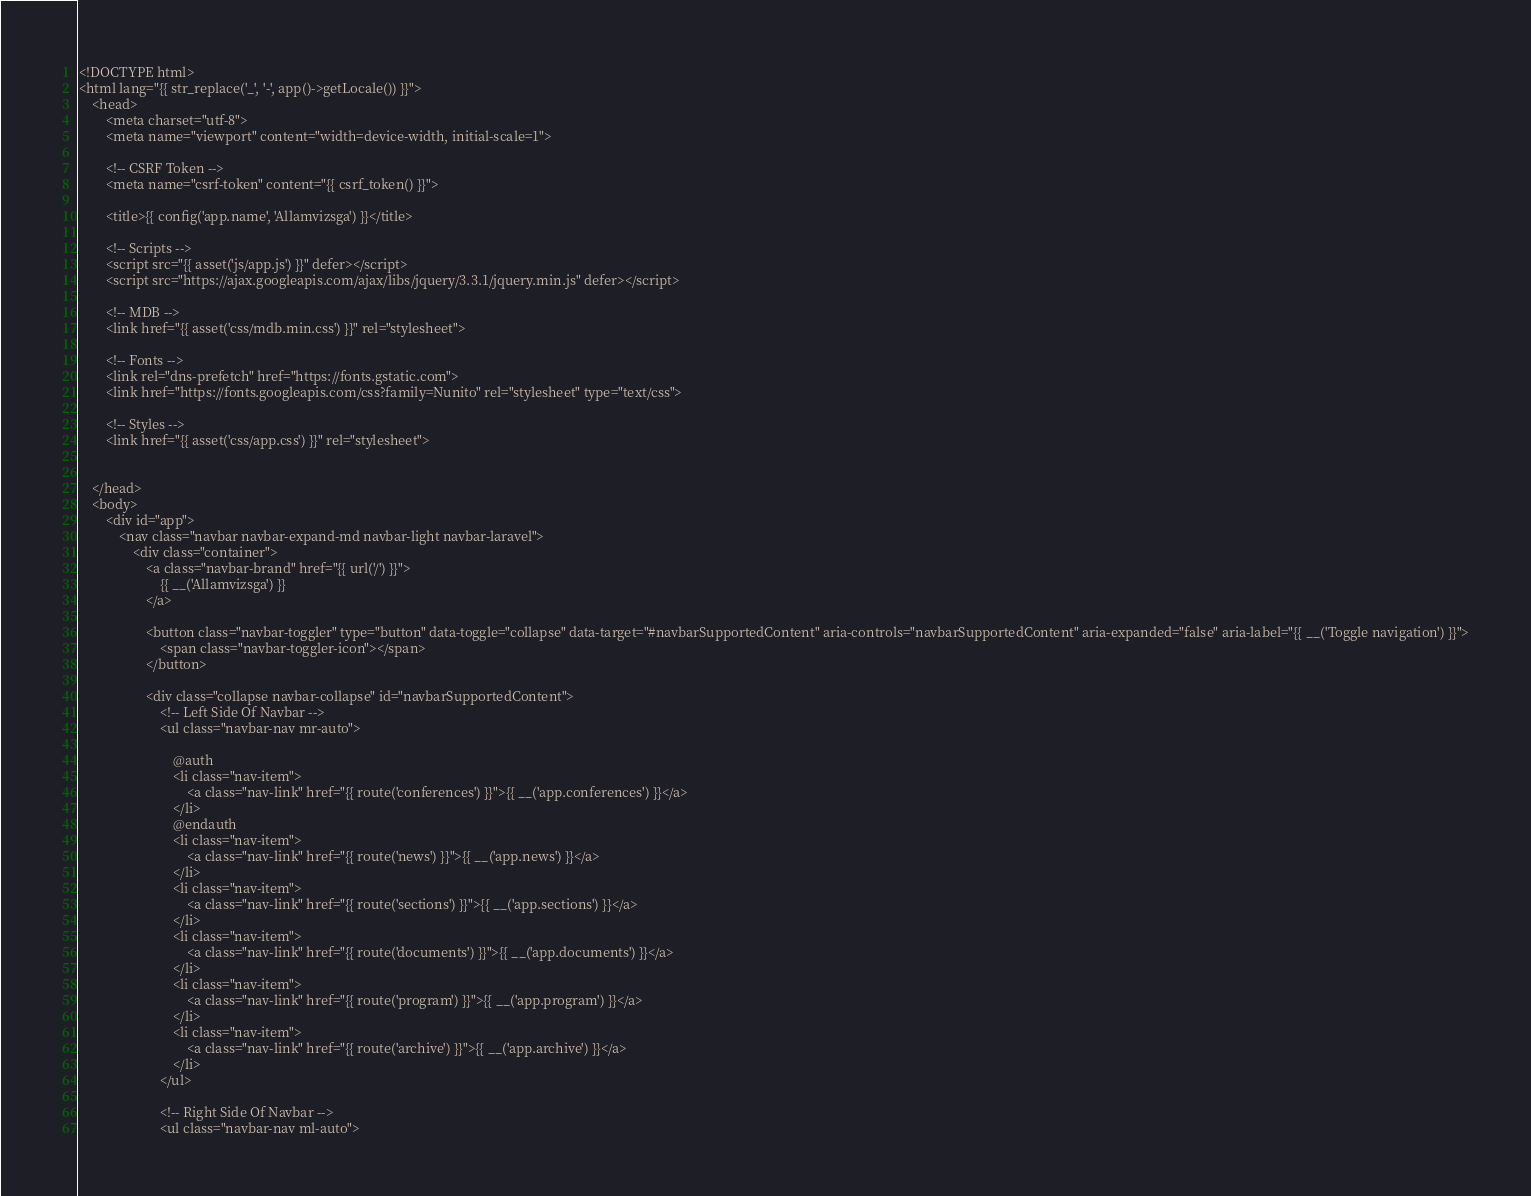Convert code to text. <code><loc_0><loc_0><loc_500><loc_500><_PHP_><!DOCTYPE html>
<html lang="{{ str_replace('_', '-', app()->getLocale()) }}">
    <head>
        <meta charset="utf-8">
        <meta name="viewport" content="width=device-width, initial-scale=1">

        <!-- CSRF Token -->
        <meta name="csrf-token" content="{{ csrf_token() }}">

        <title>{{ config('app.name', 'Allamvizsga') }}</title>

        <!-- Scripts -->
        <script src="{{ asset('js/app.js') }}" defer></script>
        <script src="https://ajax.googleapis.com/ajax/libs/jquery/3.3.1/jquery.min.js" defer></script>

        <!-- MDB -->
        <link href="{{ asset('css/mdb.min.css') }}" rel="stylesheet">

        <!-- Fonts -->
        <link rel="dns-prefetch" href="https://fonts.gstatic.com">
        <link href="https://fonts.googleapis.com/css?family=Nunito" rel="stylesheet" type="text/css">

        <!-- Styles -->
        <link href="{{ asset('css/app.css') }}" rel="stylesheet">


    </head>
    <body>
        <div id="app">
            <nav class="navbar navbar-expand-md navbar-light navbar-laravel">
                <div class="container">
                    <a class="navbar-brand" href="{{ url('/') }}">
                        {{ __('Allamvizsga') }}
                    </a>

                    <button class="navbar-toggler" type="button" data-toggle="collapse" data-target="#navbarSupportedContent" aria-controls="navbarSupportedContent" aria-expanded="false" aria-label="{{ __('Toggle navigation') }}">
                        <span class="navbar-toggler-icon"></span>
                    </button>

                    <div class="collapse navbar-collapse" id="navbarSupportedContent">
                        <!-- Left Side Of Navbar -->
                        <ul class="navbar-nav mr-auto">

                            @auth
                            <li class="nav-item">
                                <a class="nav-link" href="{{ route('conferences') }}">{{ __('app.conferences') }}</a>
                            </li>
                            @endauth
                            <li class="nav-item">
                                <a class="nav-link" href="{{ route('news') }}">{{ __('app.news') }}</a>
                            </li>
                            <li class="nav-item">
                                <a class="nav-link" href="{{ route('sections') }}">{{ __('app.sections') }}</a>
                            </li>
                            <li class="nav-item">
                                <a class="nav-link" href="{{ route('documents') }}">{{ __('app.documents') }}</a>
                            </li>
                            <li class="nav-item">
                                <a class="nav-link" href="{{ route('program') }}">{{ __('app.program') }}</a>
                            </li>
                            <li class="nav-item">
                                <a class="nav-link" href="{{ route('archive') }}">{{ __('app.archive') }}</a>
                            </li>
                        </ul>

                        <!-- Right Side Of Navbar -->
                        <ul class="navbar-nav ml-auto"></code> 